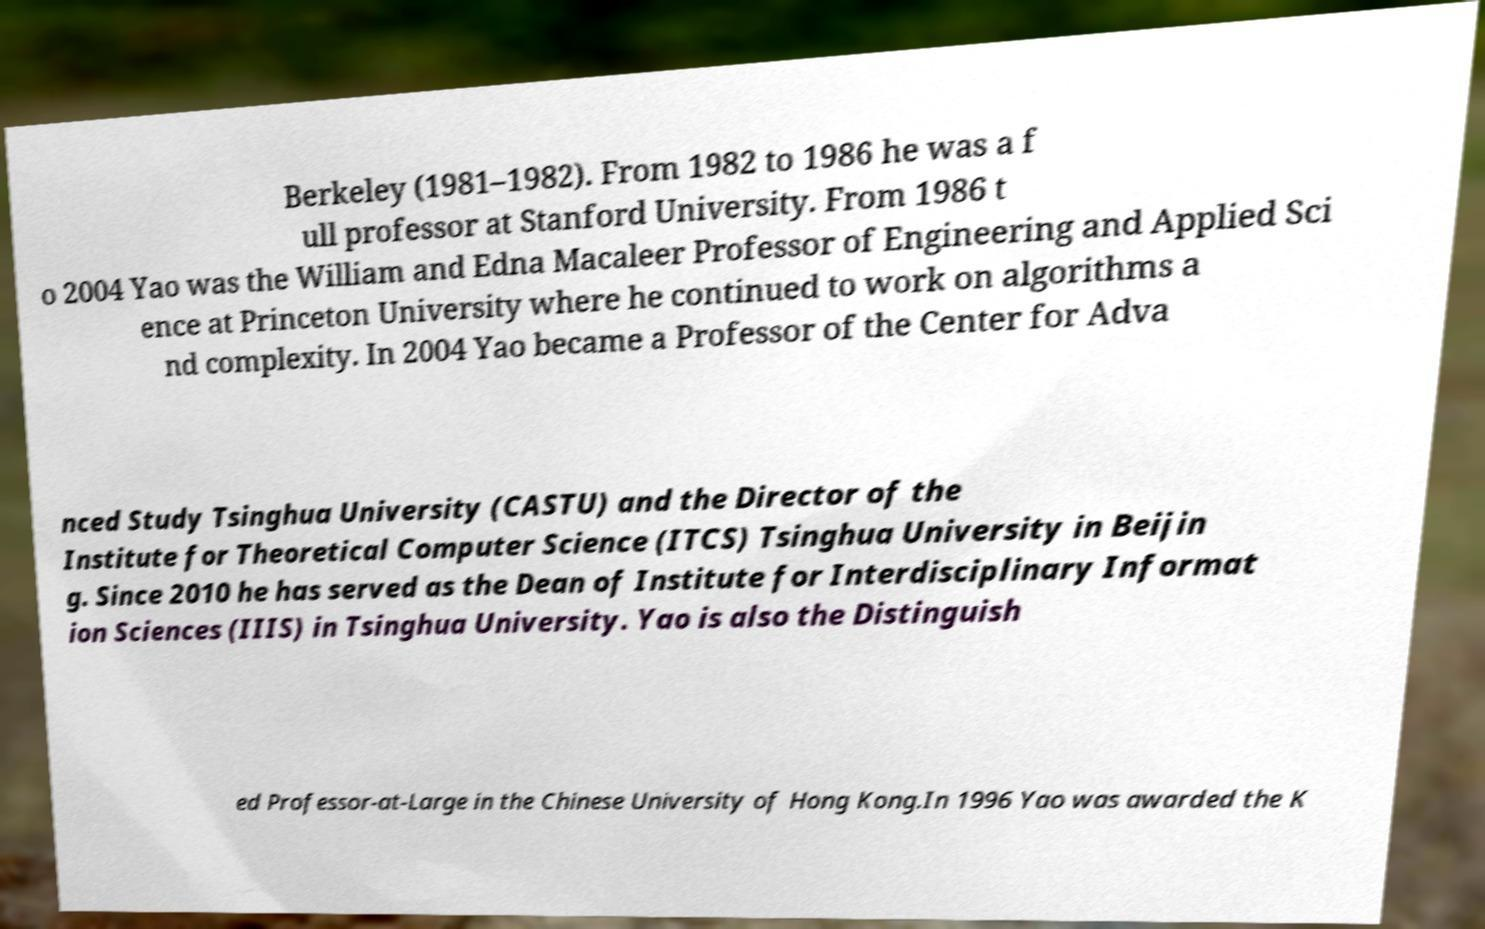Can you read and provide the text displayed in the image?This photo seems to have some interesting text. Can you extract and type it out for me? Berkeley (1981–1982). From 1982 to 1986 he was a f ull professor at Stanford University. From 1986 t o 2004 Yao was the William and Edna Macaleer Professor of Engineering and Applied Sci ence at Princeton University where he continued to work on algorithms a nd complexity. In 2004 Yao became a Professor of the Center for Adva nced Study Tsinghua University (CASTU) and the Director of the Institute for Theoretical Computer Science (ITCS) Tsinghua University in Beijin g. Since 2010 he has served as the Dean of Institute for Interdisciplinary Informat ion Sciences (IIIS) in Tsinghua University. Yao is also the Distinguish ed Professor-at-Large in the Chinese University of Hong Kong.In 1996 Yao was awarded the K 